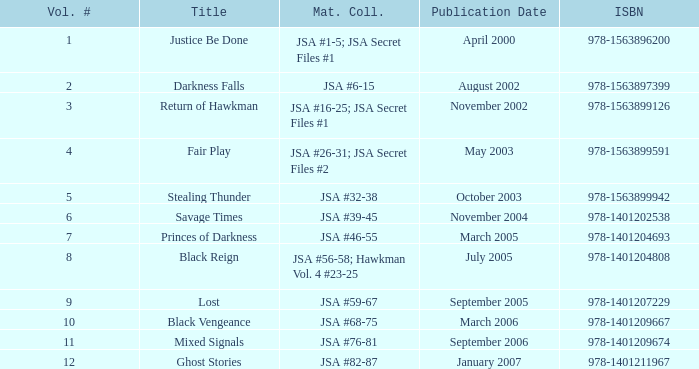What's the Material collected for the 978-1401209674 ISBN? JSA #76-81. 